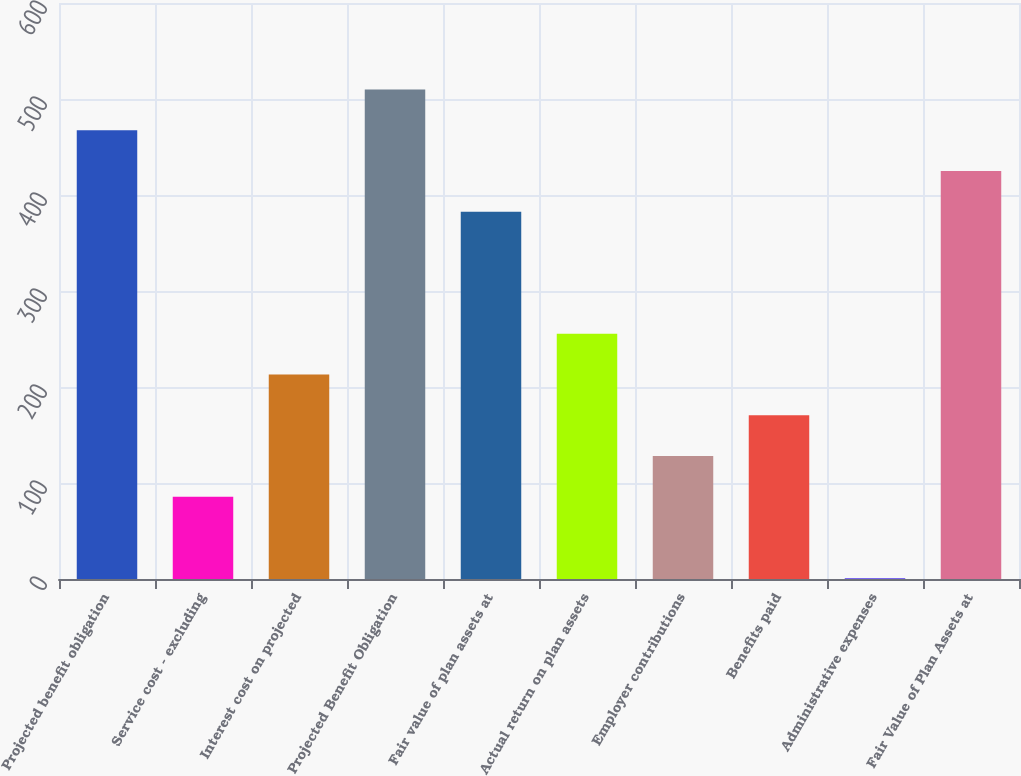Convert chart. <chart><loc_0><loc_0><loc_500><loc_500><bar_chart><fcel>Projected benefit obligation<fcel>Service cost - excluding<fcel>Interest cost on projected<fcel>Projected Benefit Obligation<fcel>Fair value of plan assets at<fcel>Actual return on plan assets<fcel>Employer contributions<fcel>Benefits paid<fcel>Administrative expenses<fcel>Fair Value of Plan Assets at<nl><fcel>467.4<fcel>85.8<fcel>213<fcel>509.8<fcel>382.6<fcel>255.4<fcel>128.2<fcel>170.6<fcel>1<fcel>425<nl></chart> 